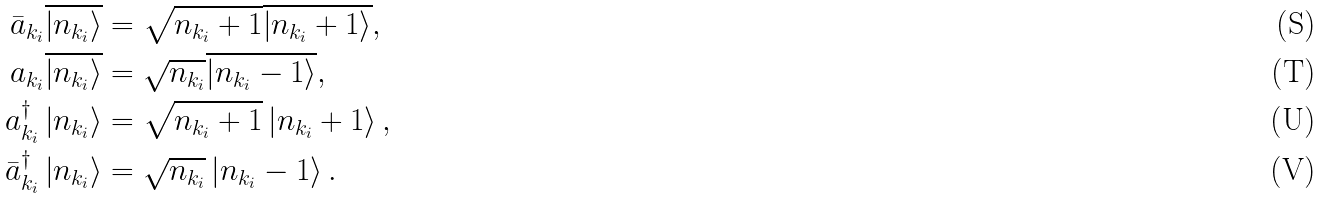<formula> <loc_0><loc_0><loc_500><loc_500>\bar { a } _ { k _ { i } } \overline { \left | n _ { k _ { i } } \right \rangle } & = \sqrt { n _ { k _ { i } } + 1 } \overline { \left | n _ { k _ { i } } + 1 \right \rangle } , \\ a _ { k _ { i } } \overline { \left | n _ { k _ { i } } \right \rangle } & = \sqrt { n _ { k _ { i } } } \overline { \left | n _ { k _ { i } } - 1 \right \rangle } , \\ a _ { k _ { i } } ^ { \dag } \left | n _ { k _ { i } } \right \rangle & = \sqrt { n _ { k _ { i } } + 1 } \left | n _ { k _ { i } } + 1 \right \rangle , \\ \bar { a } _ { k _ { i } } ^ { \dag } \left | n _ { k _ { i } } \right \rangle & = \sqrt { n _ { k _ { i } } } \left | n _ { k _ { i } } - 1 \right \rangle .</formula> 